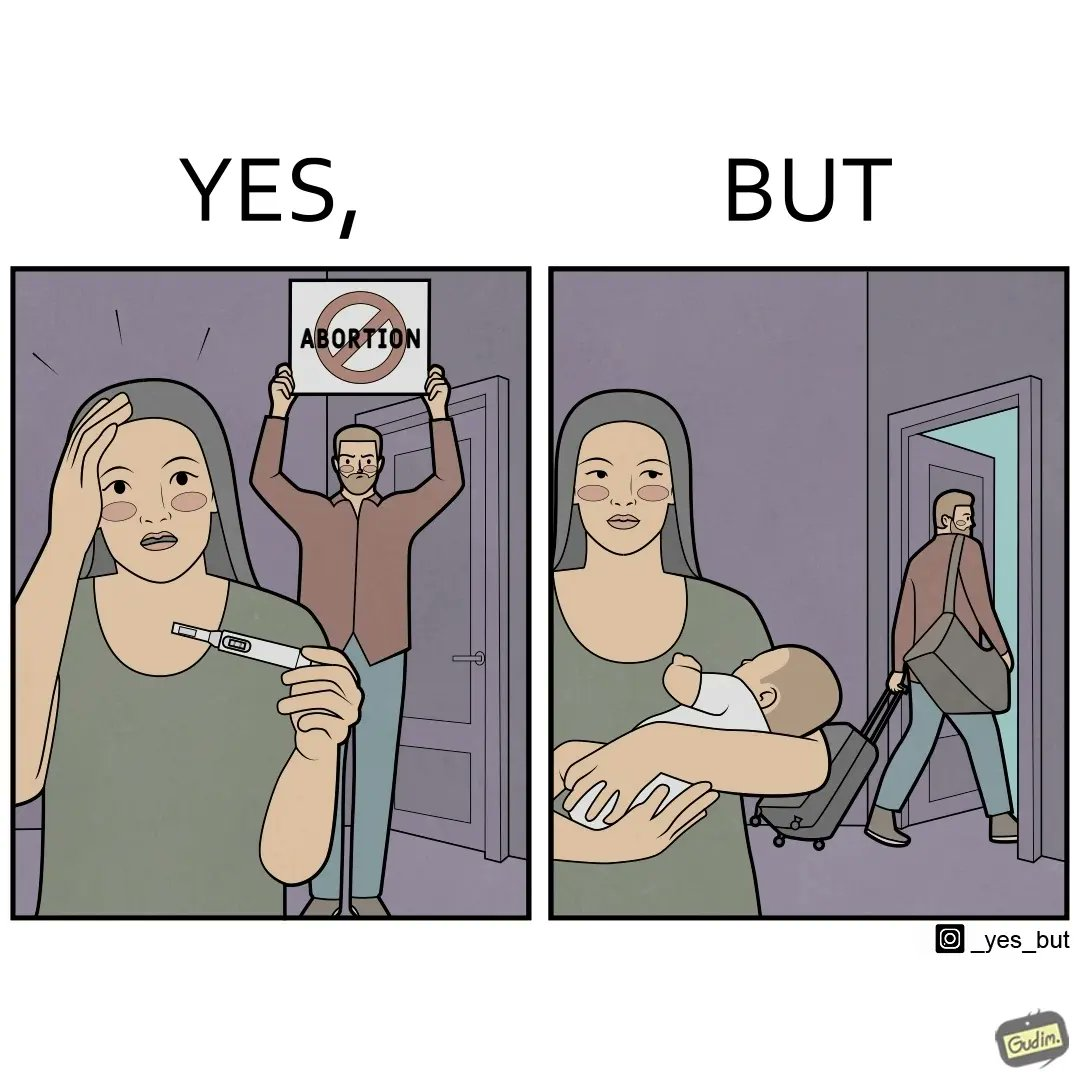What do you see in each half of this image? In the left part of the image: It is a woman with a pregnancy test showing positive results while a man is protesting against abortion In the right part of the image: It is a man leaving his partner alone with her baby 